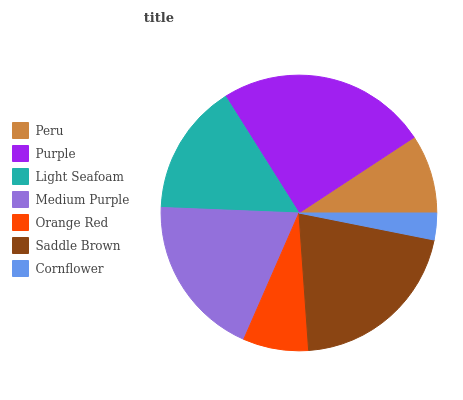Is Cornflower the minimum?
Answer yes or no. Yes. Is Purple the maximum?
Answer yes or no. Yes. Is Light Seafoam the minimum?
Answer yes or no. No. Is Light Seafoam the maximum?
Answer yes or no. No. Is Purple greater than Light Seafoam?
Answer yes or no. Yes. Is Light Seafoam less than Purple?
Answer yes or no. Yes. Is Light Seafoam greater than Purple?
Answer yes or no. No. Is Purple less than Light Seafoam?
Answer yes or no. No. Is Light Seafoam the high median?
Answer yes or no. Yes. Is Light Seafoam the low median?
Answer yes or no. Yes. Is Saddle Brown the high median?
Answer yes or no. No. Is Cornflower the low median?
Answer yes or no. No. 